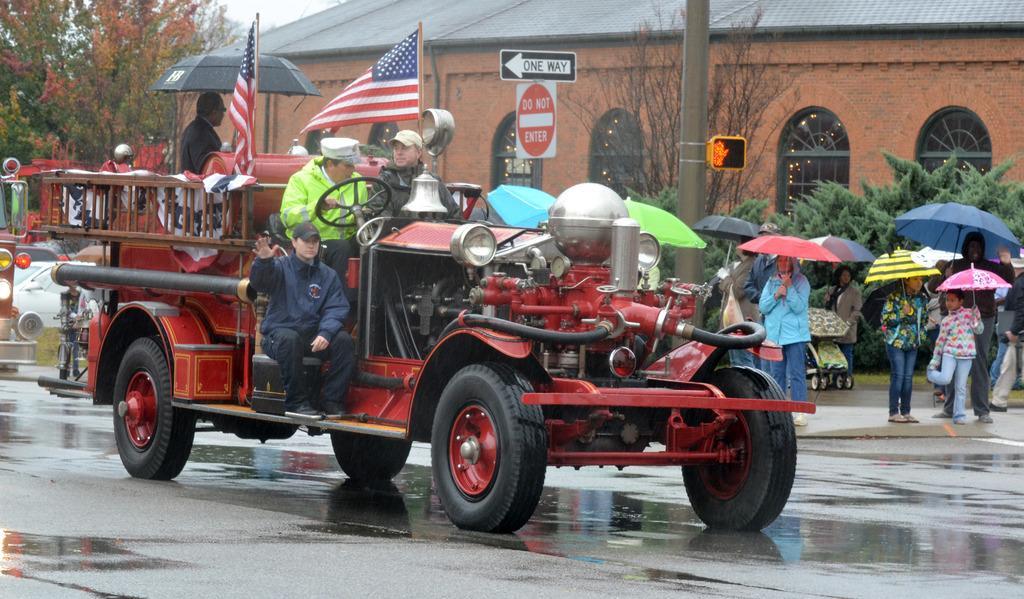In one or two sentences, can you explain what this image depicts? In this picture I can observe a red color vehicle moving on the road. There are some people sitting in the vehicle. On the right side some of the people are standing on the land holding umbrellas in their hands. I can observe a pole on the right side. In the background there are trees and a building. 